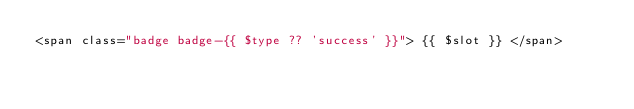<code> <loc_0><loc_0><loc_500><loc_500><_PHP_><span class="badge badge-{{ $type ?? 'success' }}"> {{ $slot }} </span>
</code> 